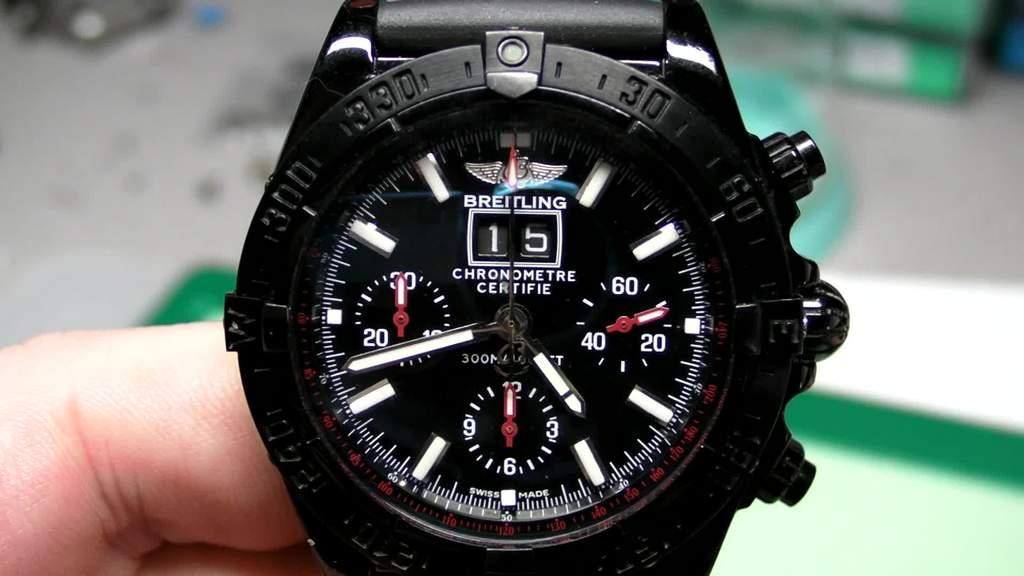Provide a one-sentence caption for the provided image. A person shows off their multi-functional watch and chronometer. 